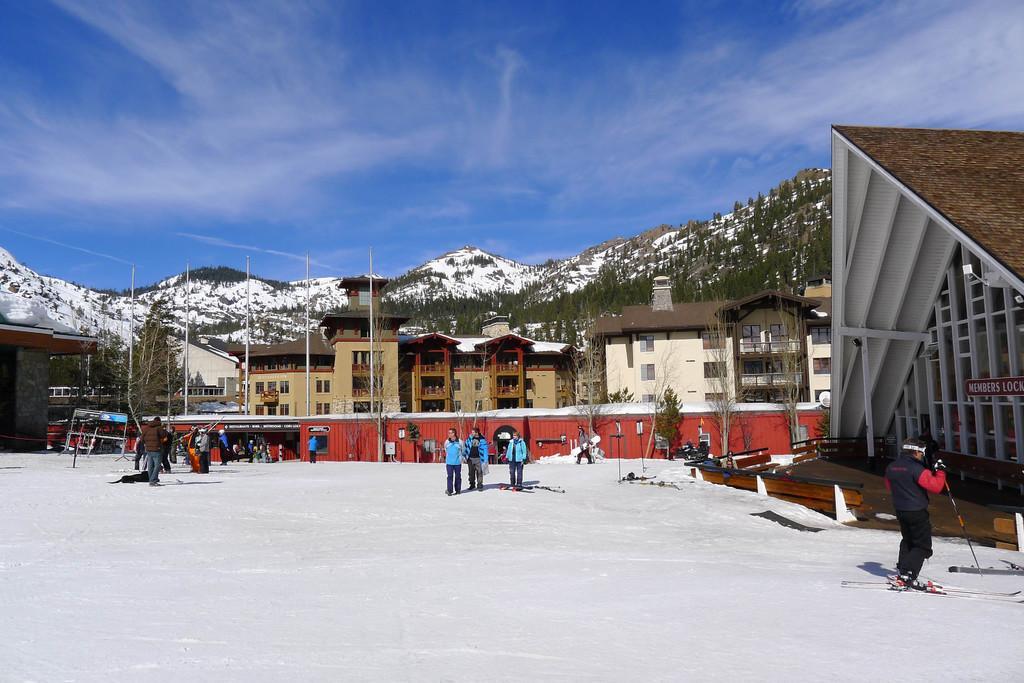How would you summarize this image in a sentence or two? In this image I can see there are persons standing in the snow and one person is holding a ski stick. And at the back there are buildings. In front of the building there is a shed. At the backside of the building there are trees, Mountain and a sky. 